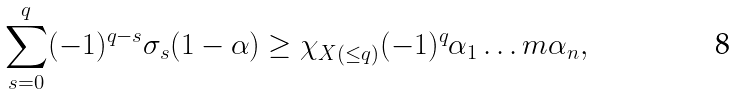<formula> <loc_0><loc_0><loc_500><loc_500>\sum _ { s = 0 } ^ { q } ( - 1 ) ^ { q - s } \sigma _ { s } ( 1 - \alpha ) \geq \chi _ { X ( \leq q ) } ( - 1 ) ^ { q } \alpha _ { 1 } \dots m \alpha _ { n } ,</formula> 